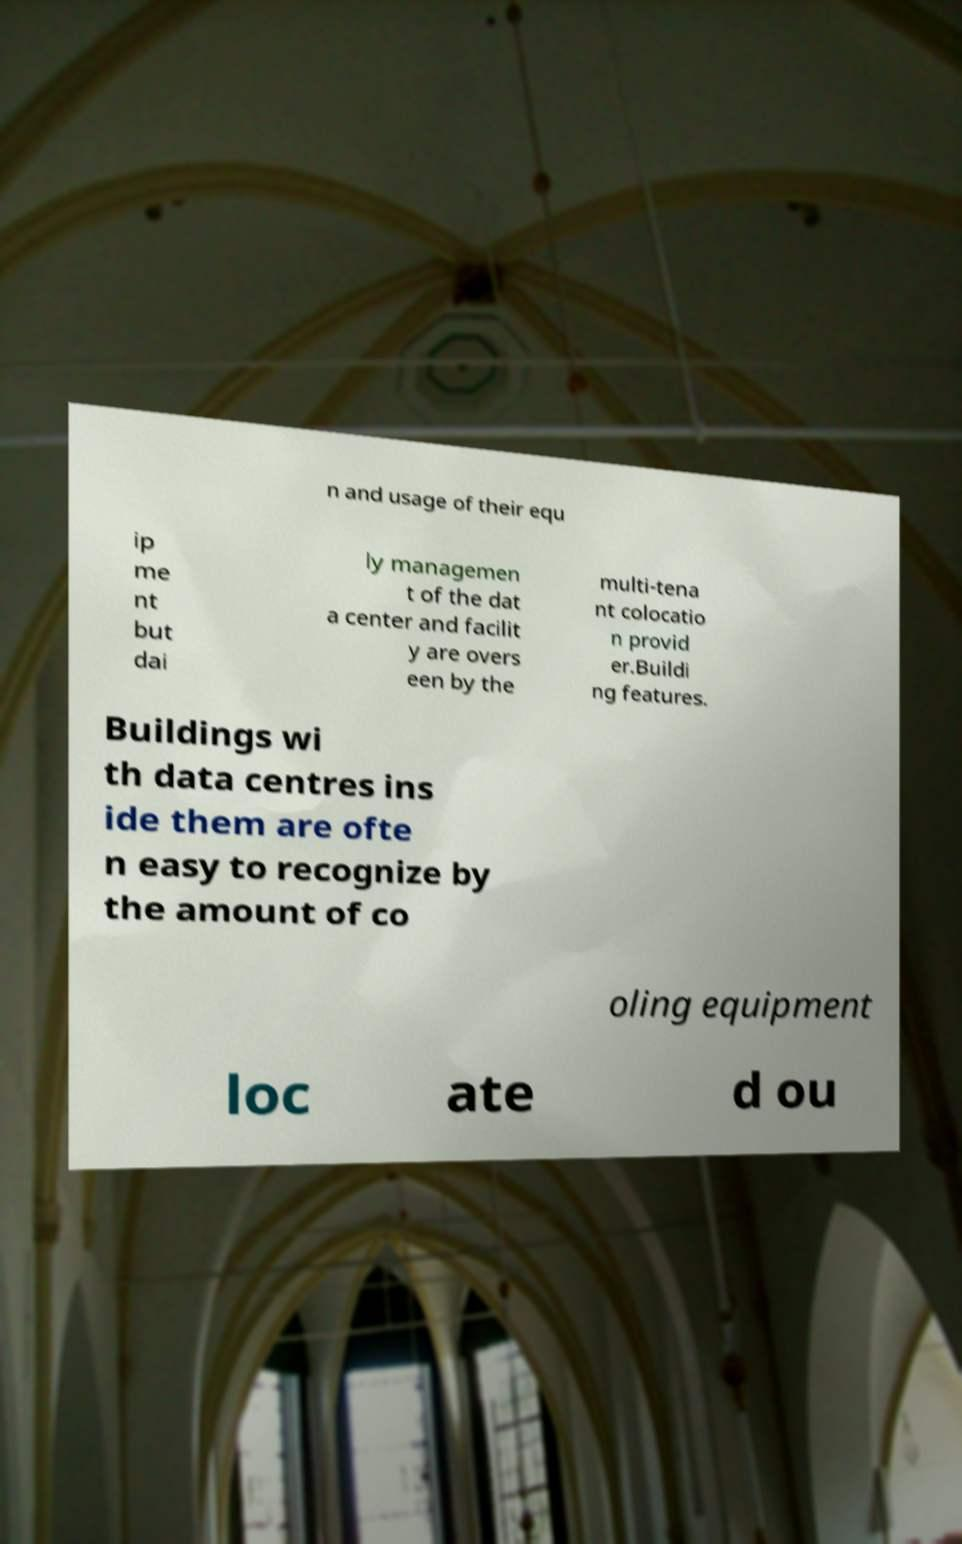Could you assist in decoding the text presented in this image and type it out clearly? n and usage of their equ ip me nt but dai ly managemen t of the dat a center and facilit y are overs een by the multi-tena nt colocatio n provid er.Buildi ng features. Buildings wi th data centres ins ide them are ofte n easy to recognize by the amount of co oling equipment loc ate d ou 